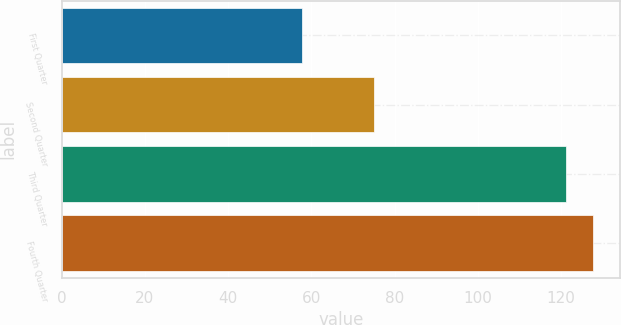Convert chart. <chart><loc_0><loc_0><loc_500><loc_500><bar_chart><fcel>First Quarter<fcel>Second Quarter<fcel>Third Quarter<fcel>Fourth Quarter<nl><fcel>57.66<fcel>75.03<fcel>121.14<fcel>127.75<nl></chart> 